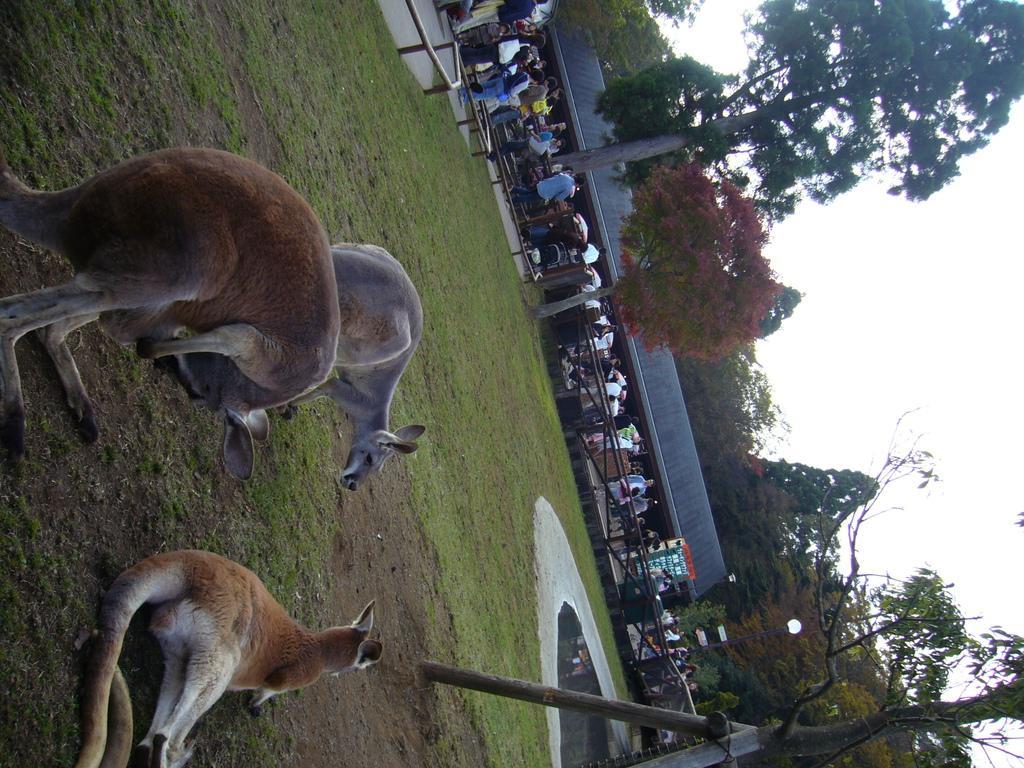Could you give a brief overview of what you see in this image? In this image we can see a few people, there are three animals, there are trees, poles, fencing, there is a shed, and a light pole, also we can see the sky. 